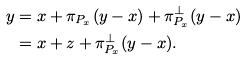<formula> <loc_0><loc_0><loc_500><loc_500>y & = x + \pi _ { P _ { x } } ( y - x ) + \pi _ { P _ { x } } ^ { \perp } ( y - x ) \\ & = x + z + \pi _ { P _ { x } } ^ { \perp } ( y - x ) .</formula> 